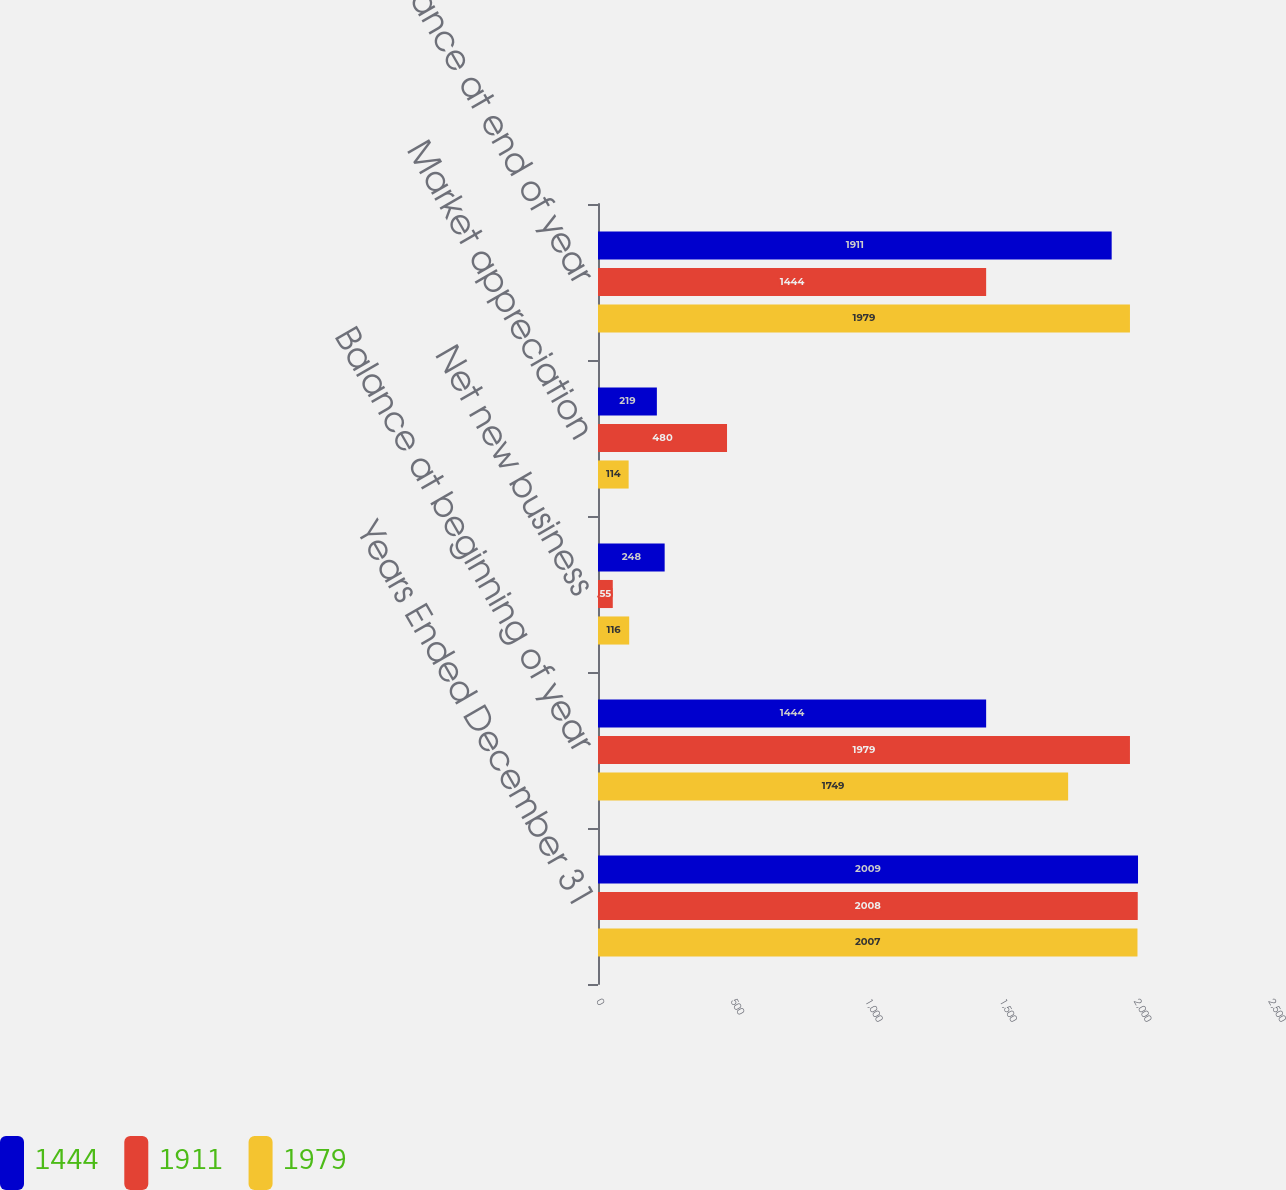<chart> <loc_0><loc_0><loc_500><loc_500><stacked_bar_chart><ecel><fcel>Years Ended December 31<fcel>Balance at beginning of year<fcel>Net new business<fcel>Market appreciation<fcel>Balance at end of year<nl><fcel>1444<fcel>2009<fcel>1444<fcel>248<fcel>219<fcel>1911<nl><fcel>1911<fcel>2008<fcel>1979<fcel>55<fcel>480<fcel>1444<nl><fcel>1979<fcel>2007<fcel>1749<fcel>116<fcel>114<fcel>1979<nl></chart> 